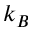Convert formula to latex. <formula><loc_0><loc_0><loc_500><loc_500>k _ { B }</formula> 